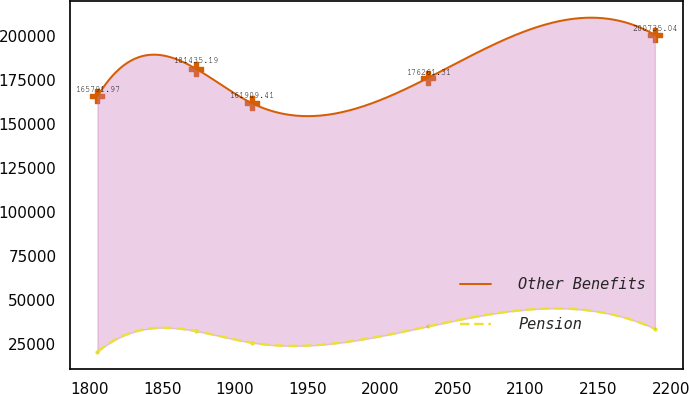<chart> <loc_0><loc_0><loc_500><loc_500><line_chart><ecel><fcel>Other Benefits<fcel>Pension<nl><fcel>1805.47<fcel>165792<fcel>20444.6<nl><fcel>1873.34<fcel>181435<fcel>32239.6<nl><fcel>1911.69<fcel>161909<fcel>25657.1<nl><fcel>2032.93<fcel>176261<fcel>34935.4<nl><fcel>2188.95<fcel>200735<fcel>33587.5<nl></chart> 